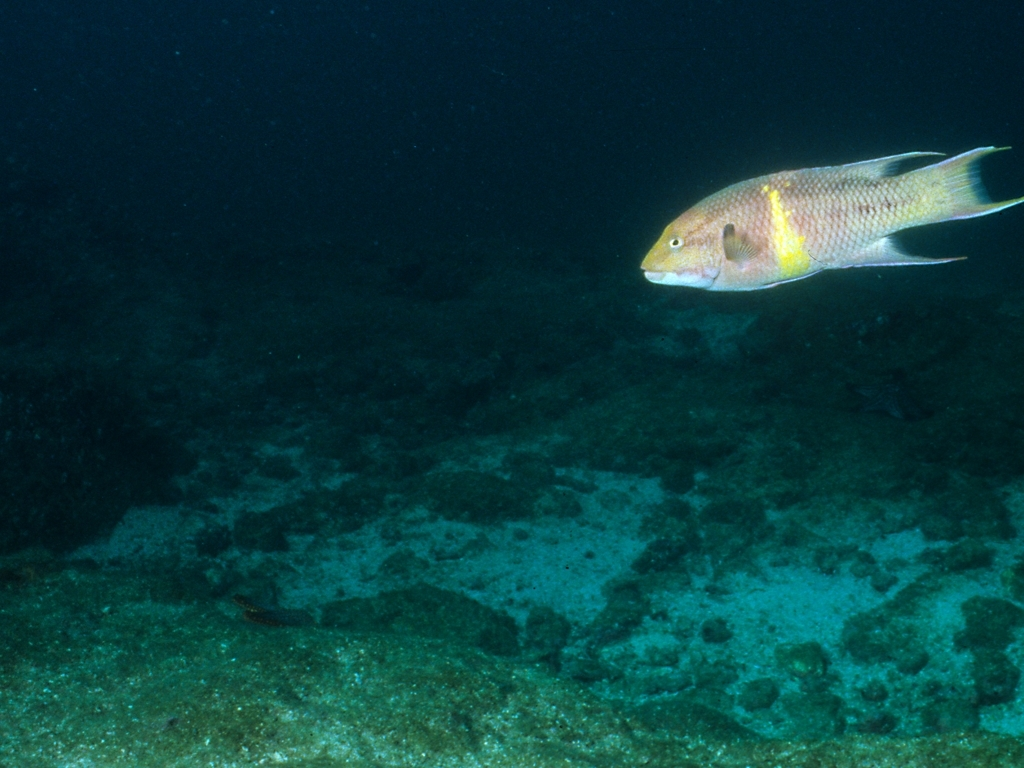What species of fish is this and what can you tell me about its habitat? Based on the photograph, this looks like a species of wrasse, likely found in tropical and subtropical waters. Wrasses typically inhabit coral reefs and rocky environments where they can find plenty of food and shelter. How does it contribute to its ecosystem? Wrasse play a vital role in their ecosystem, often serving as cleaners by picking parasites and dead skin off larger fishes. This activity contributes to the overall health of the reef community and maintains a symbiotic balance. 